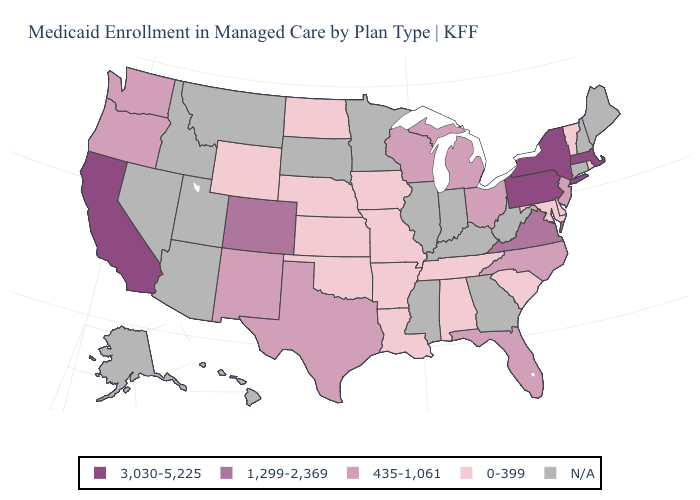Does Arkansas have the lowest value in the USA?
Give a very brief answer. Yes. Name the states that have a value in the range 435-1,061?
Give a very brief answer. Florida, Michigan, New Jersey, New Mexico, North Carolina, Ohio, Oregon, Texas, Washington, Wisconsin. What is the highest value in the USA?
Be succinct. 3,030-5,225. Does Texas have the lowest value in the USA?
Be succinct. No. What is the value of Mississippi?
Concise answer only. N/A. Name the states that have a value in the range N/A?
Quick response, please. Alaska, Arizona, Connecticut, Georgia, Hawaii, Idaho, Illinois, Indiana, Kentucky, Maine, Minnesota, Mississippi, Montana, Nevada, New Hampshire, South Dakota, Utah, West Virginia. What is the lowest value in states that border New Mexico?
Keep it brief. 0-399. Which states have the lowest value in the West?
Short answer required. Wyoming. What is the highest value in states that border Nevada?
Be succinct. 3,030-5,225. Does the first symbol in the legend represent the smallest category?
Answer briefly. No. Does Massachusetts have the lowest value in the USA?
Give a very brief answer. No. Which states have the highest value in the USA?
Concise answer only. California, Massachusetts, New York, Pennsylvania. What is the highest value in the South ?
Be succinct. 1,299-2,369. Is the legend a continuous bar?
Concise answer only. No. 